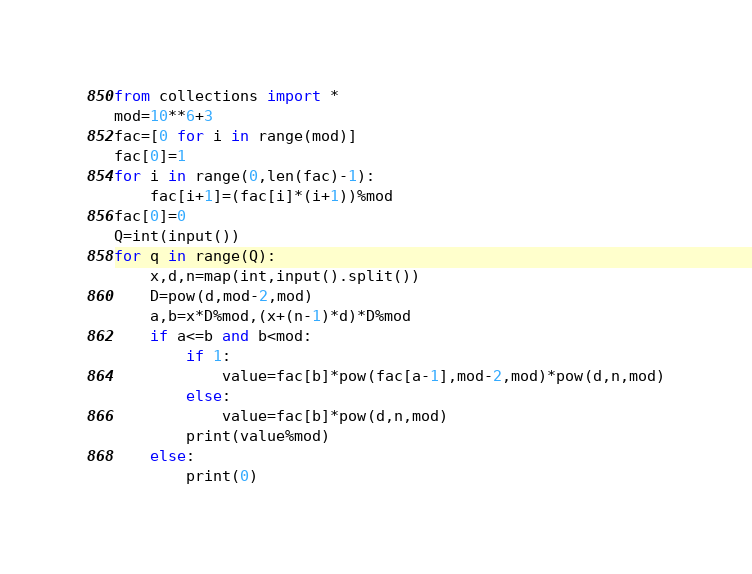Convert code to text. <code><loc_0><loc_0><loc_500><loc_500><_Python_>from collections import *
mod=10**6+3
fac=[0 for i in range(mod)]
fac[0]=1
for i in range(0,len(fac)-1):
    fac[i+1]=(fac[i]*(i+1))%mod
fac[0]=0
Q=int(input())
for q in range(Q):
    x,d,n=map(int,input().split())
    D=pow(d,mod-2,mod)
    a,b=x*D%mod,(x+(n-1)*d)*D%mod
    if a<=b and b<mod:
        if 1:
            value=fac[b]*pow(fac[a-1],mod-2,mod)*pow(d,n,mod)
        else:
            value=fac[b]*pow(d,n,mod)
        print(value%mod)
    else:
        print(0)
</code> 